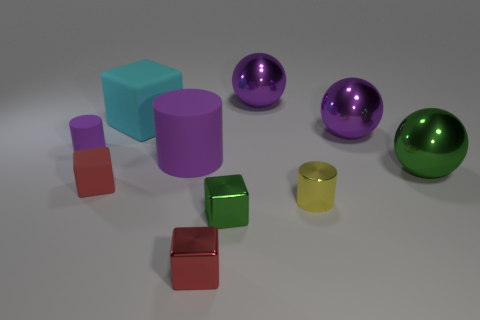Are there fewer purple matte cylinders in front of the big green metal thing than tiny red rubber things to the right of the green block?
Provide a short and direct response. No. What number of tiny things are there?
Offer a terse response. 5. There is a cube that is behind the tiny matte cylinder; what color is it?
Offer a very short reply. Cyan. The cyan matte thing is what size?
Offer a terse response. Large. There is a large cylinder; is it the same color as the small cylinder that is to the left of the big cyan rubber block?
Keep it short and to the point. Yes. There is a large ball that is in front of the purple cylinder left of the tiny red matte block; what color is it?
Give a very brief answer. Green. Is there anything else that has the same size as the green sphere?
Provide a short and direct response. Yes. There is a red object right of the large purple matte cylinder; is its shape the same as the yellow object?
Ensure brevity in your answer.  No. How many tiny metallic things are on the right side of the green metallic cube and to the left of the shiny cylinder?
Give a very brief answer. 0. What is the color of the large matte object that is behind the purple rubber cylinder that is on the right side of the small block behind the yellow shiny object?
Provide a succinct answer. Cyan. 